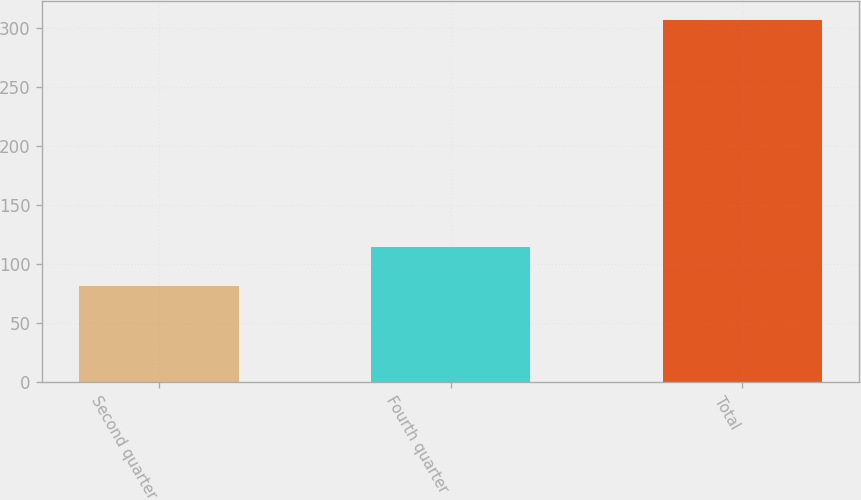<chart> <loc_0><loc_0><loc_500><loc_500><bar_chart><fcel>Second quarter<fcel>Fourth quarter<fcel>Total<nl><fcel>81<fcel>114<fcel>307<nl></chart> 